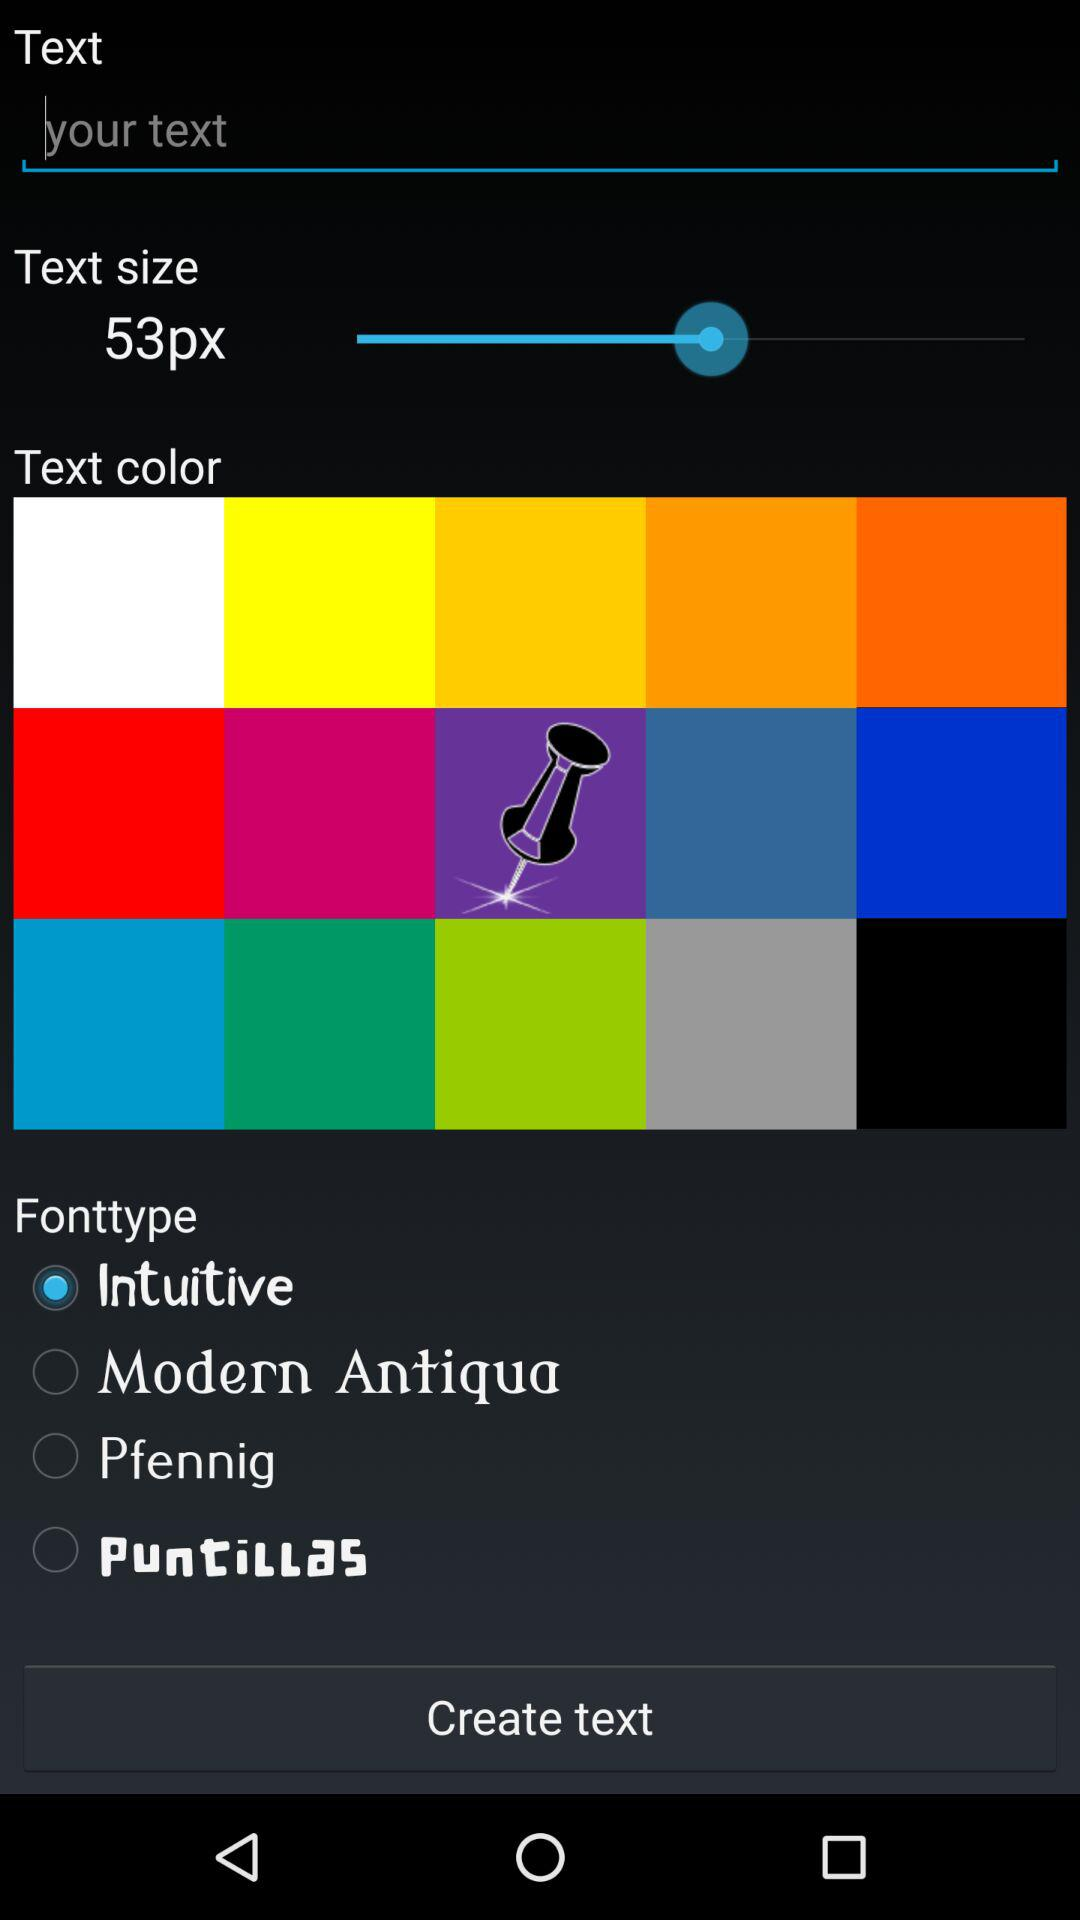How many font types are there?
Answer the question using a single word or phrase. 4 